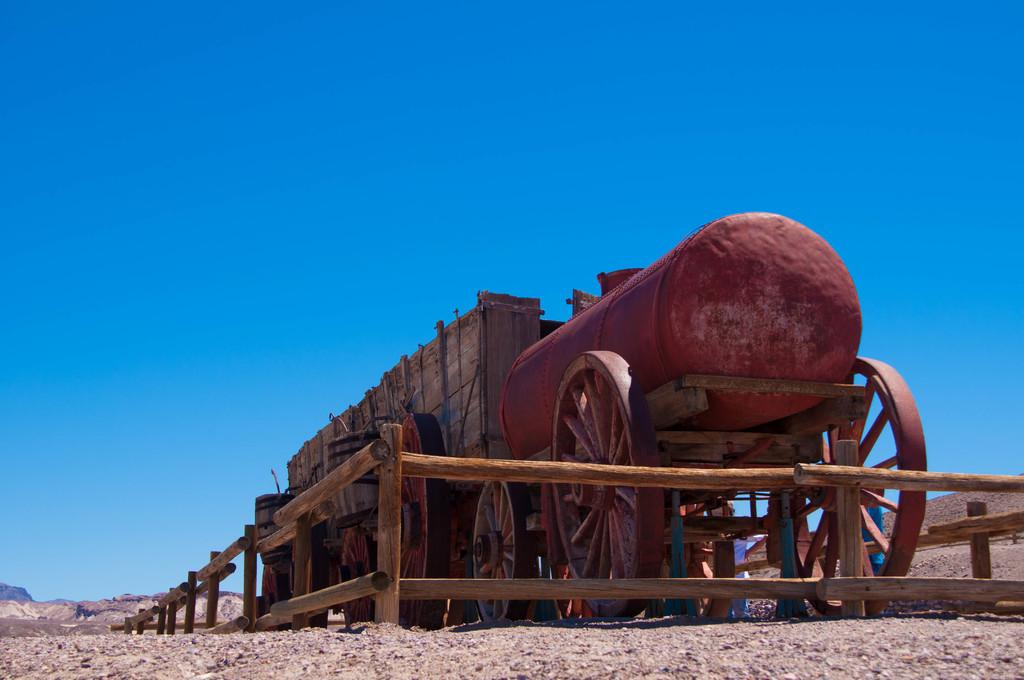What is the main object in the image? There is a cart in the image. What is on top of the cart? An iron barrel is on the cart. What type of barrier can be seen in the image? There is a wooden fence in the image. What can be seen at the bottom of the image? The ground is visible at the bottom of the image. What is visible at the top of the image? The sky is visible at the top of the image. How many bears are sitting on the cart in the image? There are no bears present in the image; it features a cart with an iron barrel on top. What type of cannon is visible on the wooden fence in the image? There is no cannon present on the wooden fence or anywhere else in the image. 